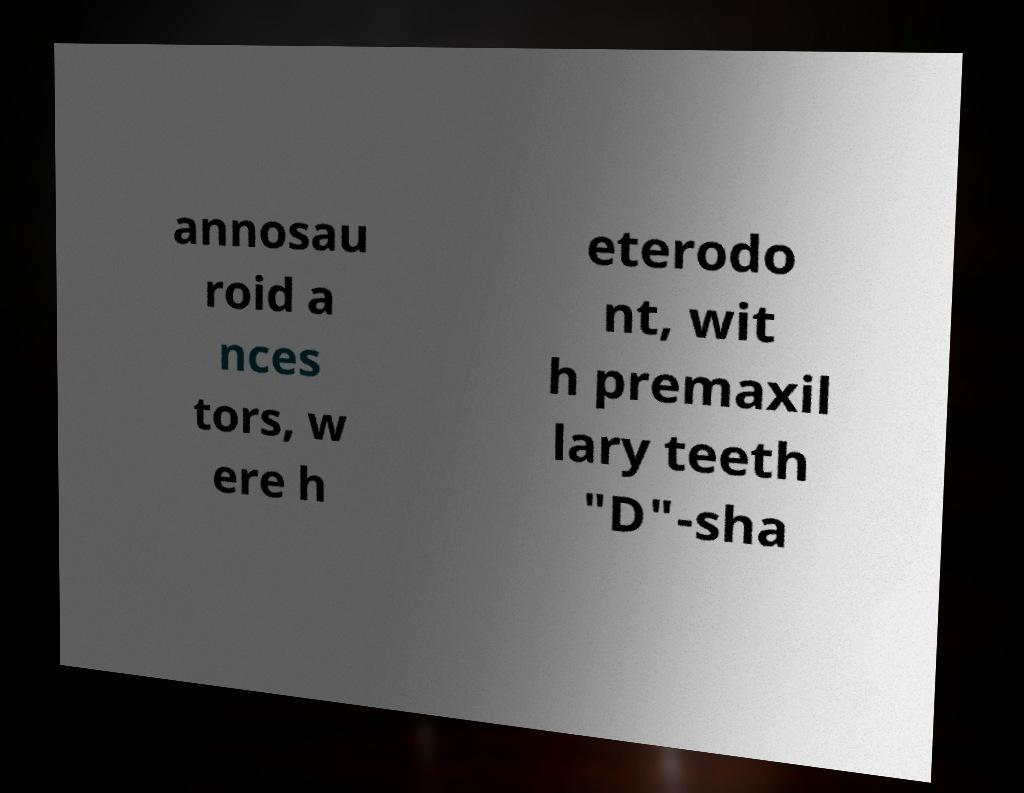Can you read and provide the text displayed in the image?This photo seems to have some interesting text. Can you extract and type it out for me? annosau roid a nces tors, w ere h eterodo nt, wit h premaxil lary teeth "D"-sha 